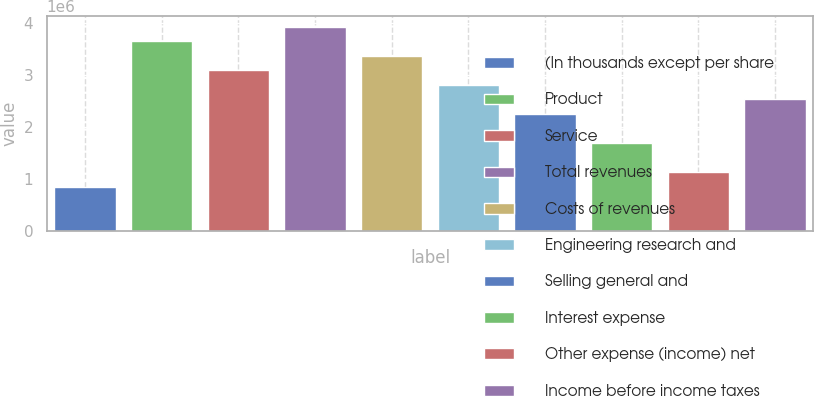Convert chart to OTSL. <chart><loc_0><loc_0><loc_500><loc_500><bar_chart><fcel>(In thousands except per share<fcel>Product<fcel>Service<fcel>Total revenues<fcel>Costs of revenues<fcel>Engineering research and<fcel>Selling general and<fcel>Interest expense<fcel>Other expense (income) net<fcel>Income before income taxes<nl><fcel>844216<fcel>3.65826e+06<fcel>3.09545e+06<fcel>3.93967e+06<fcel>3.37686e+06<fcel>2.81405e+06<fcel>2.25124e+06<fcel>1.68843e+06<fcel>1.12562e+06<fcel>2.53264e+06<nl></chart> 